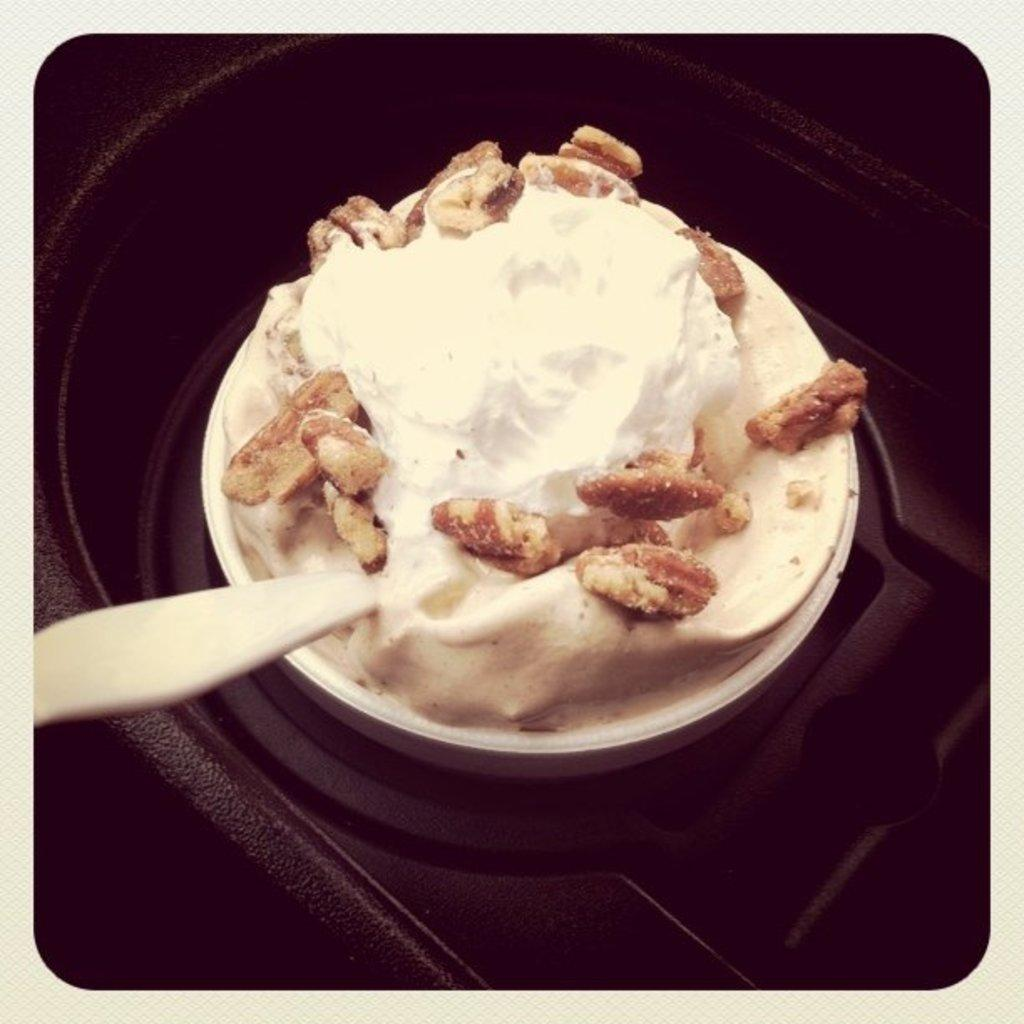What can be seen in the image related to food? There is food in the image. What utensil is present in the image? There is a spoon in the cup. How does the food grow in the image? The image does not show any food growing; it only shows prepared food. 